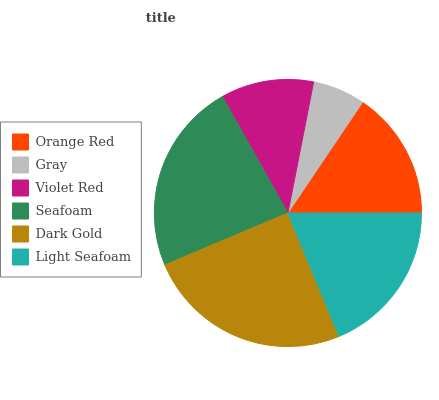Is Gray the minimum?
Answer yes or no. Yes. Is Dark Gold the maximum?
Answer yes or no. Yes. Is Violet Red the minimum?
Answer yes or no. No. Is Violet Red the maximum?
Answer yes or no. No. Is Violet Red greater than Gray?
Answer yes or no. Yes. Is Gray less than Violet Red?
Answer yes or no. Yes. Is Gray greater than Violet Red?
Answer yes or no. No. Is Violet Red less than Gray?
Answer yes or no. No. Is Light Seafoam the high median?
Answer yes or no. Yes. Is Orange Red the low median?
Answer yes or no. Yes. Is Violet Red the high median?
Answer yes or no. No. Is Seafoam the low median?
Answer yes or no. No. 